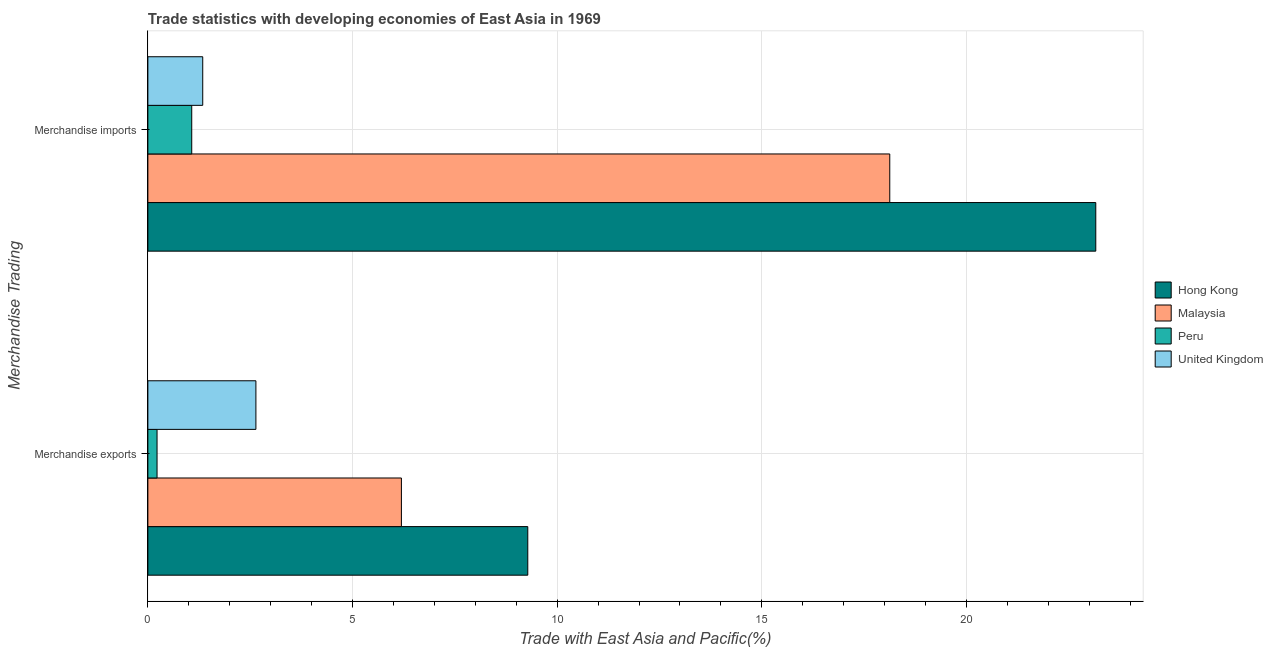How many different coloured bars are there?
Your response must be concise. 4. How many groups of bars are there?
Provide a short and direct response. 2. What is the merchandise imports in Peru?
Ensure brevity in your answer.  1.07. Across all countries, what is the maximum merchandise exports?
Your answer should be compact. 9.28. Across all countries, what is the minimum merchandise exports?
Provide a succinct answer. 0.22. In which country was the merchandise imports maximum?
Your response must be concise. Hong Kong. What is the total merchandise exports in the graph?
Offer a terse response. 18.34. What is the difference between the merchandise imports in Peru and that in Malaysia?
Your response must be concise. -17.05. What is the difference between the merchandise imports in Peru and the merchandise exports in Malaysia?
Keep it short and to the point. -5.12. What is the average merchandise exports per country?
Your answer should be very brief. 4.58. What is the difference between the merchandise imports and merchandise exports in United Kingdom?
Keep it short and to the point. -1.3. In how many countries, is the merchandise exports greater than 8 %?
Offer a very short reply. 1. What is the ratio of the merchandise exports in Peru to that in Hong Kong?
Provide a short and direct response. 0.02. Is the merchandise exports in Hong Kong less than that in Malaysia?
Offer a very short reply. No. In how many countries, is the merchandise imports greater than the average merchandise imports taken over all countries?
Provide a succinct answer. 2. What does the 3rd bar from the top in Merchandise imports represents?
Provide a short and direct response. Malaysia. Are all the bars in the graph horizontal?
Provide a short and direct response. Yes. How many countries are there in the graph?
Provide a short and direct response. 4. Are the values on the major ticks of X-axis written in scientific E-notation?
Your answer should be very brief. No. Does the graph contain any zero values?
Offer a terse response. No. Does the graph contain grids?
Keep it short and to the point. Yes. Where does the legend appear in the graph?
Your response must be concise. Center right. How many legend labels are there?
Make the answer very short. 4. What is the title of the graph?
Your answer should be very brief. Trade statistics with developing economies of East Asia in 1969. What is the label or title of the X-axis?
Your answer should be compact. Trade with East Asia and Pacific(%). What is the label or title of the Y-axis?
Give a very brief answer. Merchandise Trading. What is the Trade with East Asia and Pacific(%) in Hong Kong in Merchandise exports?
Ensure brevity in your answer.  9.28. What is the Trade with East Asia and Pacific(%) in Malaysia in Merchandise exports?
Give a very brief answer. 6.19. What is the Trade with East Asia and Pacific(%) of Peru in Merchandise exports?
Give a very brief answer. 0.22. What is the Trade with East Asia and Pacific(%) in United Kingdom in Merchandise exports?
Your answer should be compact. 2.64. What is the Trade with East Asia and Pacific(%) in Hong Kong in Merchandise imports?
Give a very brief answer. 23.16. What is the Trade with East Asia and Pacific(%) of Malaysia in Merchandise imports?
Your answer should be very brief. 18.13. What is the Trade with East Asia and Pacific(%) of Peru in Merchandise imports?
Offer a terse response. 1.07. What is the Trade with East Asia and Pacific(%) of United Kingdom in Merchandise imports?
Give a very brief answer. 1.34. Across all Merchandise Trading, what is the maximum Trade with East Asia and Pacific(%) of Hong Kong?
Your response must be concise. 23.16. Across all Merchandise Trading, what is the maximum Trade with East Asia and Pacific(%) in Malaysia?
Your answer should be very brief. 18.13. Across all Merchandise Trading, what is the maximum Trade with East Asia and Pacific(%) in Peru?
Make the answer very short. 1.07. Across all Merchandise Trading, what is the maximum Trade with East Asia and Pacific(%) of United Kingdom?
Provide a short and direct response. 2.64. Across all Merchandise Trading, what is the minimum Trade with East Asia and Pacific(%) in Hong Kong?
Keep it short and to the point. 9.28. Across all Merchandise Trading, what is the minimum Trade with East Asia and Pacific(%) in Malaysia?
Offer a very short reply. 6.19. Across all Merchandise Trading, what is the minimum Trade with East Asia and Pacific(%) in Peru?
Your answer should be compact. 0.22. Across all Merchandise Trading, what is the minimum Trade with East Asia and Pacific(%) in United Kingdom?
Your answer should be very brief. 1.34. What is the total Trade with East Asia and Pacific(%) in Hong Kong in the graph?
Keep it short and to the point. 32.44. What is the total Trade with East Asia and Pacific(%) of Malaysia in the graph?
Make the answer very short. 24.32. What is the total Trade with East Asia and Pacific(%) in Peru in the graph?
Give a very brief answer. 1.3. What is the total Trade with East Asia and Pacific(%) of United Kingdom in the graph?
Make the answer very short. 3.98. What is the difference between the Trade with East Asia and Pacific(%) of Hong Kong in Merchandise exports and that in Merchandise imports?
Your response must be concise. -13.88. What is the difference between the Trade with East Asia and Pacific(%) of Malaysia in Merchandise exports and that in Merchandise imports?
Your answer should be very brief. -11.93. What is the difference between the Trade with East Asia and Pacific(%) of Peru in Merchandise exports and that in Merchandise imports?
Keep it short and to the point. -0.85. What is the difference between the Trade with East Asia and Pacific(%) of United Kingdom in Merchandise exports and that in Merchandise imports?
Provide a short and direct response. 1.3. What is the difference between the Trade with East Asia and Pacific(%) in Hong Kong in Merchandise exports and the Trade with East Asia and Pacific(%) in Malaysia in Merchandise imports?
Provide a succinct answer. -8.84. What is the difference between the Trade with East Asia and Pacific(%) in Hong Kong in Merchandise exports and the Trade with East Asia and Pacific(%) in Peru in Merchandise imports?
Give a very brief answer. 8.21. What is the difference between the Trade with East Asia and Pacific(%) of Hong Kong in Merchandise exports and the Trade with East Asia and Pacific(%) of United Kingdom in Merchandise imports?
Your response must be concise. 7.94. What is the difference between the Trade with East Asia and Pacific(%) in Malaysia in Merchandise exports and the Trade with East Asia and Pacific(%) in Peru in Merchandise imports?
Offer a terse response. 5.12. What is the difference between the Trade with East Asia and Pacific(%) in Malaysia in Merchandise exports and the Trade with East Asia and Pacific(%) in United Kingdom in Merchandise imports?
Your response must be concise. 4.85. What is the difference between the Trade with East Asia and Pacific(%) in Peru in Merchandise exports and the Trade with East Asia and Pacific(%) in United Kingdom in Merchandise imports?
Offer a very short reply. -1.12. What is the average Trade with East Asia and Pacific(%) in Hong Kong per Merchandise Trading?
Your answer should be compact. 16.22. What is the average Trade with East Asia and Pacific(%) of Malaysia per Merchandise Trading?
Ensure brevity in your answer.  12.16. What is the average Trade with East Asia and Pacific(%) in Peru per Merchandise Trading?
Your response must be concise. 0.65. What is the average Trade with East Asia and Pacific(%) in United Kingdom per Merchandise Trading?
Provide a succinct answer. 1.99. What is the difference between the Trade with East Asia and Pacific(%) in Hong Kong and Trade with East Asia and Pacific(%) in Malaysia in Merchandise exports?
Offer a terse response. 3.09. What is the difference between the Trade with East Asia and Pacific(%) in Hong Kong and Trade with East Asia and Pacific(%) in Peru in Merchandise exports?
Offer a very short reply. 9.06. What is the difference between the Trade with East Asia and Pacific(%) in Hong Kong and Trade with East Asia and Pacific(%) in United Kingdom in Merchandise exports?
Ensure brevity in your answer.  6.64. What is the difference between the Trade with East Asia and Pacific(%) of Malaysia and Trade with East Asia and Pacific(%) of Peru in Merchandise exports?
Offer a terse response. 5.97. What is the difference between the Trade with East Asia and Pacific(%) of Malaysia and Trade with East Asia and Pacific(%) of United Kingdom in Merchandise exports?
Make the answer very short. 3.55. What is the difference between the Trade with East Asia and Pacific(%) in Peru and Trade with East Asia and Pacific(%) in United Kingdom in Merchandise exports?
Keep it short and to the point. -2.42. What is the difference between the Trade with East Asia and Pacific(%) of Hong Kong and Trade with East Asia and Pacific(%) of Malaysia in Merchandise imports?
Provide a succinct answer. 5.03. What is the difference between the Trade with East Asia and Pacific(%) in Hong Kong and Trade with East Asia and Pacific(%) in Peru in Merchandise imports?
Your answer should be very brief. 22.09. What is the difference between the Trade with East Asia and Pacific(%) in Hong Kong and Trade with East Asia and Pacific(%) in United Kingdom in Merchandise imports?
Your answer should be compact. 21.82. What is the difference between the Trade with East Asia and Pacific(%) in Malaysia and Trade with East Asia and Pacific(%) in Peru in Merchandise imports?
Your answer should be compact. 17.05. What is the difference between the Trade with East Asia and Pacific(%) of Malaysia and Trade with East Asia and Pacific(%) of United Kingdom in Merchandise imports?
Your answer should be very brief. 16.78. What is the difference between the Trade with East Asia and Pacific(%) of Peru and Trade with East Asia and Pacific(%) of United Kingdom in Merchandise imports?
Ensure brevity in your answer.  -0.27. What is the ratio of the Trade with East Asia and Pacific(%) of Hong Kong in Merchandise exports to that in Merchandise imports?
Your answer should be compact. 0.4. What is the ratio of the Trade with East Asia and Pacific(%) in Malaysia in Merchandise exports to that in Merchandise imports?
Offer a terse response. 0.34. What is the ratio of the Trade with East Asia and Pacific(%) in Peru in Merchandise exports to that in Merchandise imports?
Your response must be concise. 0.21. What is the ratio of the Trade with East Asia and Pacific(%) of United Kingdom in Merchandise exports to that in Merchandise imports?
Your response must be concise. 1.97. What is the difference between the highest and the second highest Trade with East Asia and Pacific(%) of Hong Kong?
Ensure brevity in your answer.  13.88. What is the difference between the highest and the second highest Trade with East Asia and Pacific(%) in Malaysia?
Make the answer very short. 11.93. What is the difference between the highest and the second highest Trade with East Asia and Pacific(%) in Peru?
Give a very brief answer. 0.85. What is the difference between the highest and the second highest Trade with East Asia and Pacific(%) in United Kingdom?
Provide a succinct answer. 1.3. What is the difference between the highest and the lowest Trade with East Asia and Pacific(%) in Hong Kong?
Give a very brief answer. 13.88. What is the difference between the highest and the lowest Trade with East Asia and Pacific(%) of Malaysia?
Your answer should be very brief. 11.93. What is the difference between the highest and the lowest Trade with East Asia and Pacific(%) in Peru?
Give a very brief answer. 0.85. What is the difference between the highest and the lowest Trade with East Asia and Pacific(%) in United Kingdom?
Your answer should be very brief. 1.3. 